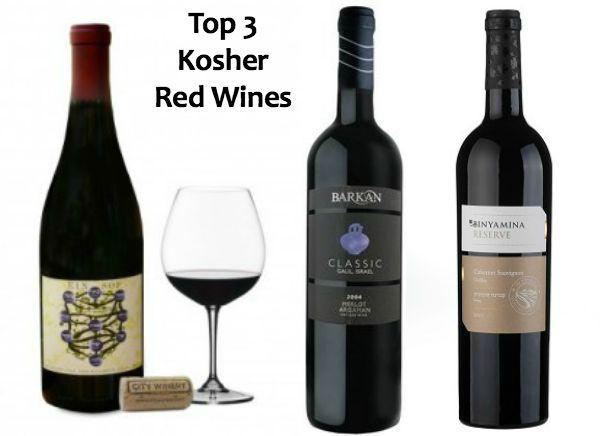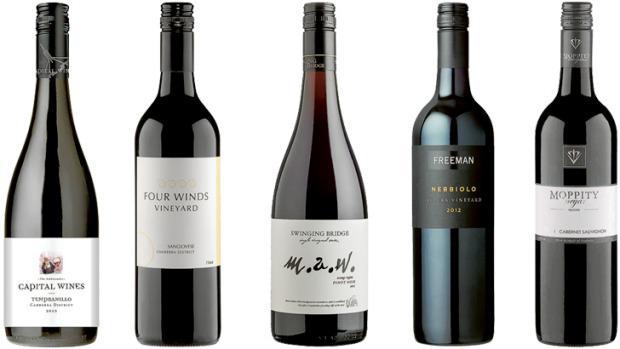The first image is the image on the left, the second image is the image on the right. Analyze the images presented: Is the assertion "Each image shows a single upright wine bottle, and at least one bottle has a red cap wrap." valid? Answer yes or no. No. The first image is the image on the left, the second image is the image on the right. Examine the images to the left and right. Is the description "Two bottles of wine, one in each image, are sealed closed and have different labels on the body of the bottle." accurate? Answer yes or no. No. 